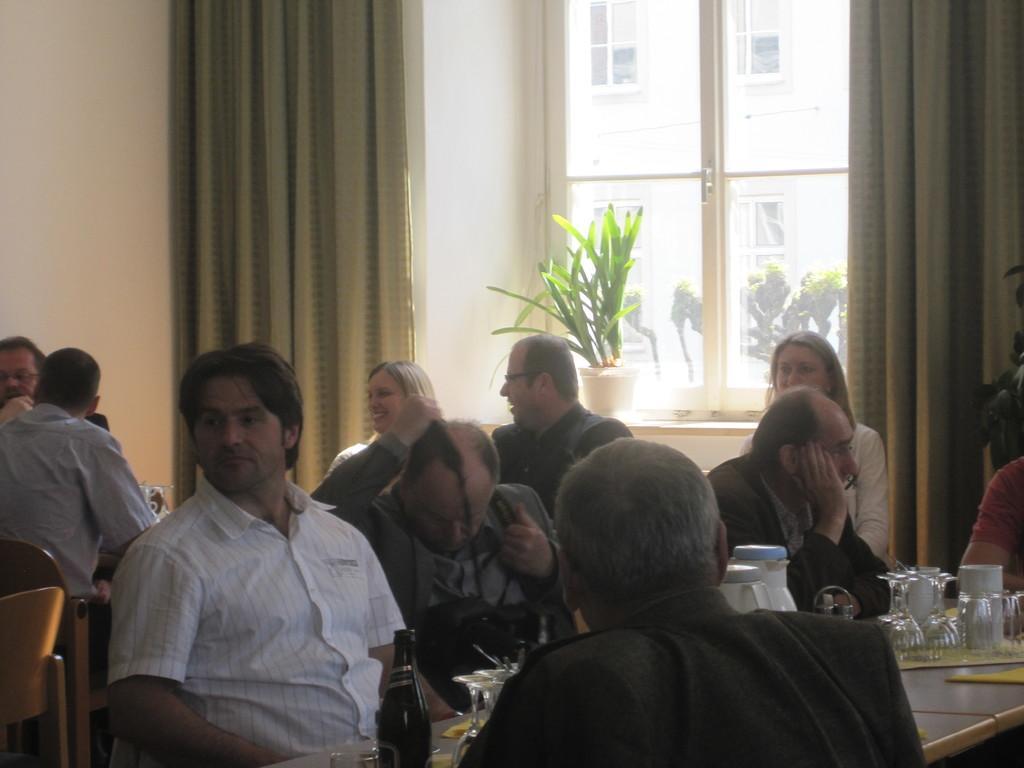Describe this image in one or two sentences. It is a restaurant, in front of the first dining table there are some people sitting, on the table there are glasses,flask and bottles, to the right side there is a window and a plant in front of the window outside the window that is a building, in the background there is a wall and beside the wall there are two curtains. 